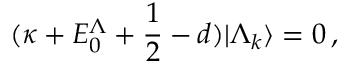<formula> <loc_0><loc_0><loc_500><loc_500>( \kappa + E _ { 0 } ^ { \Lambda } + \frac { 1 } { 2 } - d ) | \Lambda _ { k } \rangle = 0 \, ,</formula> 